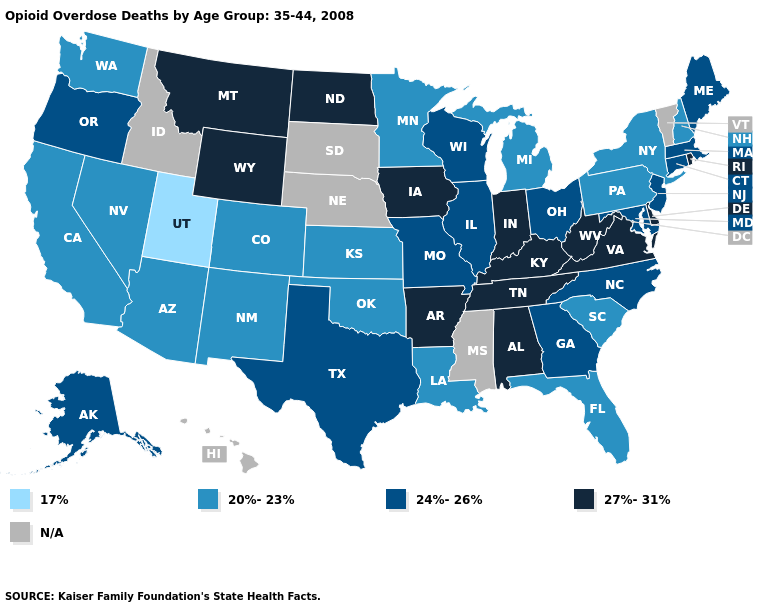Does the first symbol in the legend represent the smallest category?
Answer briefly. Yes. Name the states that have a value in the range 24%-26%?
Short answer required. Alaska, Connecticut, Georgia, Illinois, Maine, Maryland, Massachusetts, Missouri, New Jersey, North Carolina, Ohio, Oregon, Texas, Wisconsin. Among the states that border Delaware , which have the lowest value?
Short answer required. Pennsylvania. Name the states that have a value in the range 17%?
Quick response, please. Utah. What is the lowest value in states that border Minnesota?
Be succinct. 24%-26%. What is the value of Georgia?
Quick response, please. 24%-26%. Which states have the highest value in the USA?
Short answer required. Alabama, Arkansas, Delaware, Indiana, Iowa, Kentucky, Montana, North Dakota, Rhode Island, Tennessee, Virginia, West Virginia, Wyoming. Does the map have missing data?
Write a very short answer. Yes. Among the states that border New Jersey , does Delaware have the highest value?
Write a very short answer. Yes. Does Wyoming have the highest value in the USA?
Concise answer only. Yes. Among the states that border South Carolina , which have the highest value?
Write a very short answer. Georgia, North Carolina. What is the lowest value in the West?
Short answer required. 17%. Name the states that have a value in the range 20%-23%?
Be succinct. Arizona, California, Colorado, Florida, Kansas, Louisiana, Michigan, Minnesota, Nevada, New Hampshire, New Mexico, New York, Oklahoma, Pennsylvania, South Carolina, Washington. 